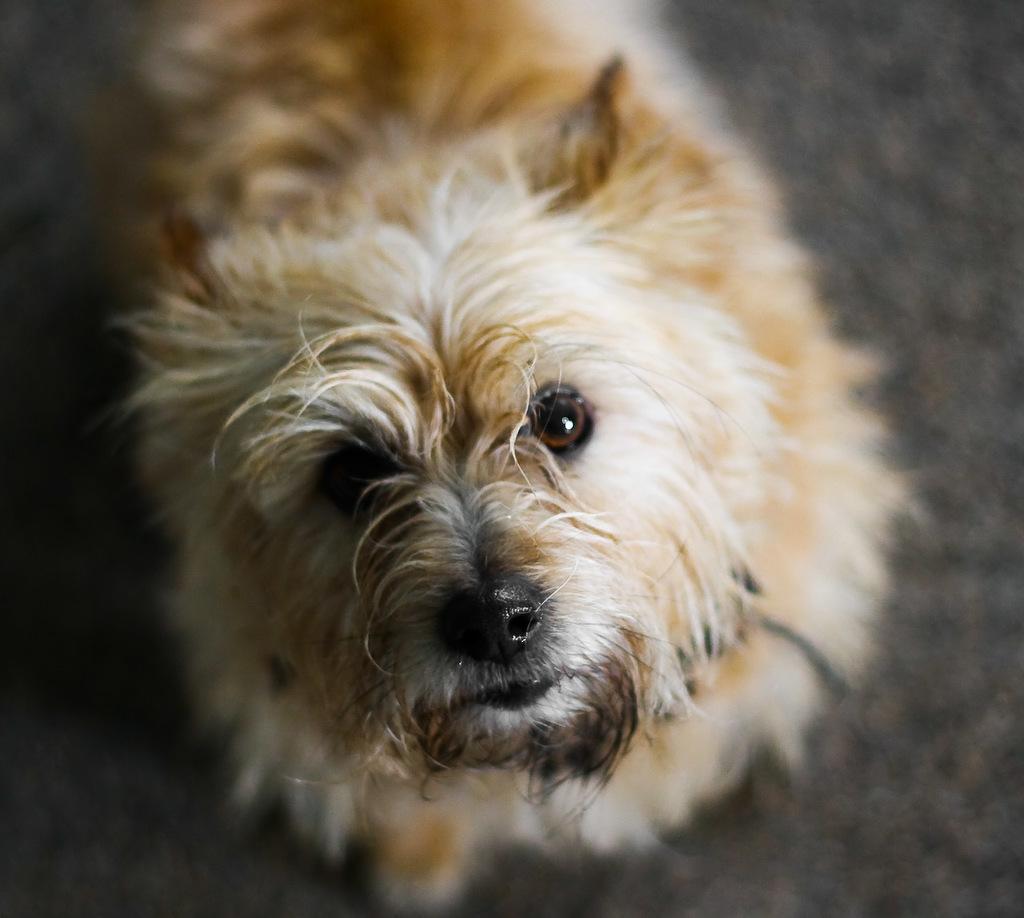Describe this image in one or two sentences. In this picture, we can see a dog is standing on the path. 